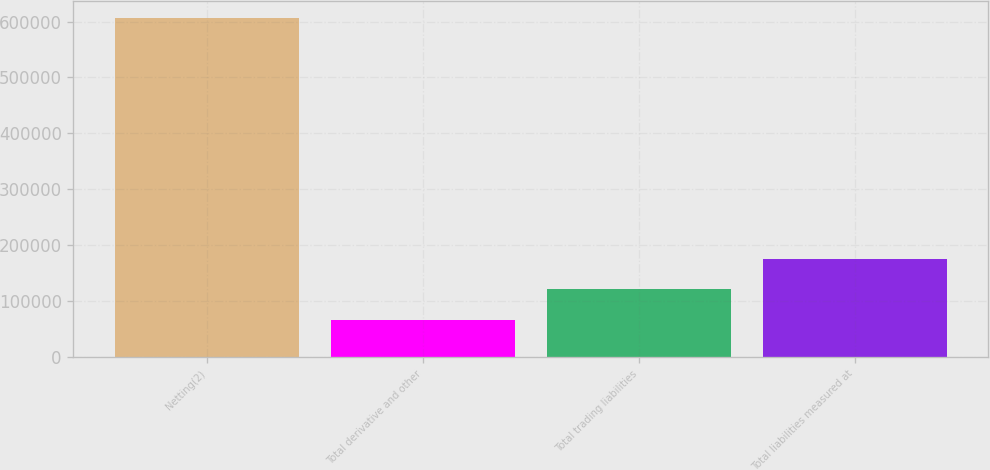Convert chart. <chart><loc_0><loc_0><loc_500><loc_500><bar_chart><fcel>Netting(2)<fcel>Total derivative and other<fcel>Total trading liabilities<fcel>Total liabilities measured at<nl><fcel>606878<fcel>66348<fcel>120401<fcel>174454<nl></chart> 